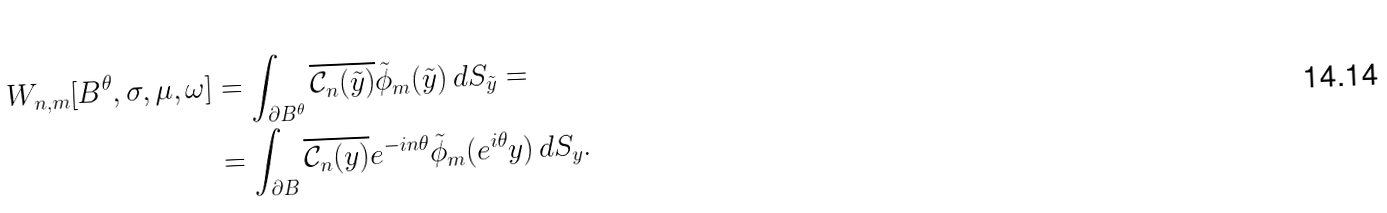Convert formula to latex. <formula><loc_0><loc_0><loc_500><loc_500>W _ { n , m } [ B ^ { \theta } , \sigma , \mu , \omega ] & = \int _ { \partial B ^ { \theta } } \overline { \mathcal { C } _ { n } ( \tilde { y } ) } \tilde { \phi } _ { m } ( \tilde { y } ) \, d S _ { \tilde { y } } = \\ & = \int _ { \partial B } \overline { \mathcal { C } _ { n } ( y ) } e ^ { - i n { \theta } } \tilde { \phi } _ { m } ( e ^ { i \theta } y ) \, d S _ { y } .</formula> 